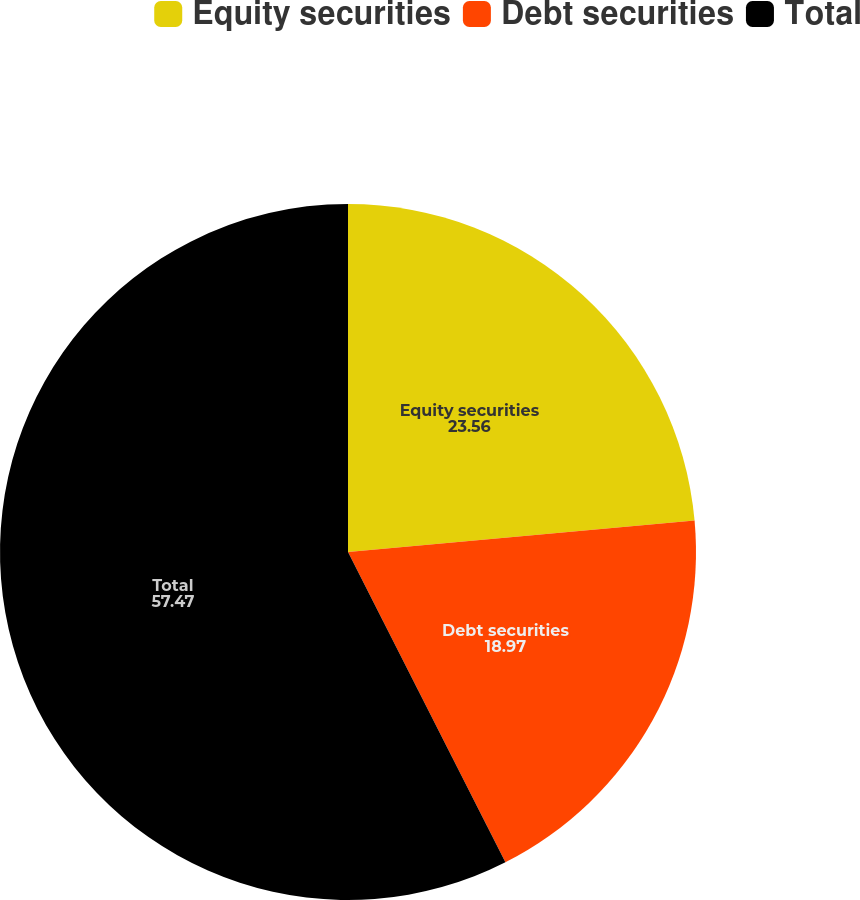Convert chart to OTSL. <chart><loc_0><loc_0><loc_500><loc_500><pie_chart><fcel>Equity securities<fcel>Debt securities<fcel>Total<nl><fcel>23.56%<fcel>18.97%<fcel>57.47%<nl></chart> 